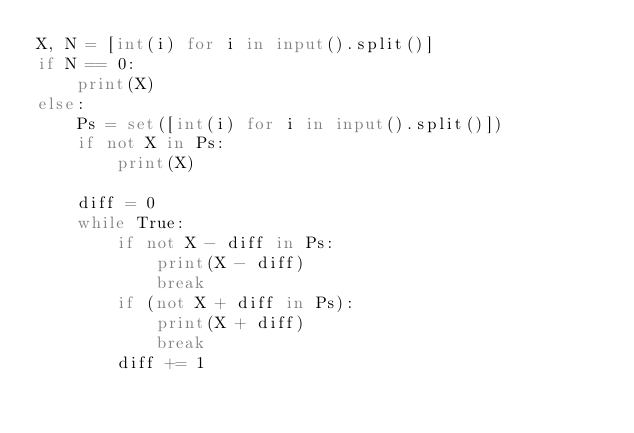Convert code to text. <code><loc_0><loc_0><loc_500><loc_500><_Python_>X, N = [int(i) for i in input().split()]
if N == 0:
    print(X)
else:
    Ps = set([int(i) for i in input().split()])
    if not X in Ps:
        print(X)

    diff = 0
    while True:
        if not X - diff in Ps:
            print(X - diff)
            break
        if (not X + diff in Ps):
            print(X + diff)
            break
        diff += 1</code> 